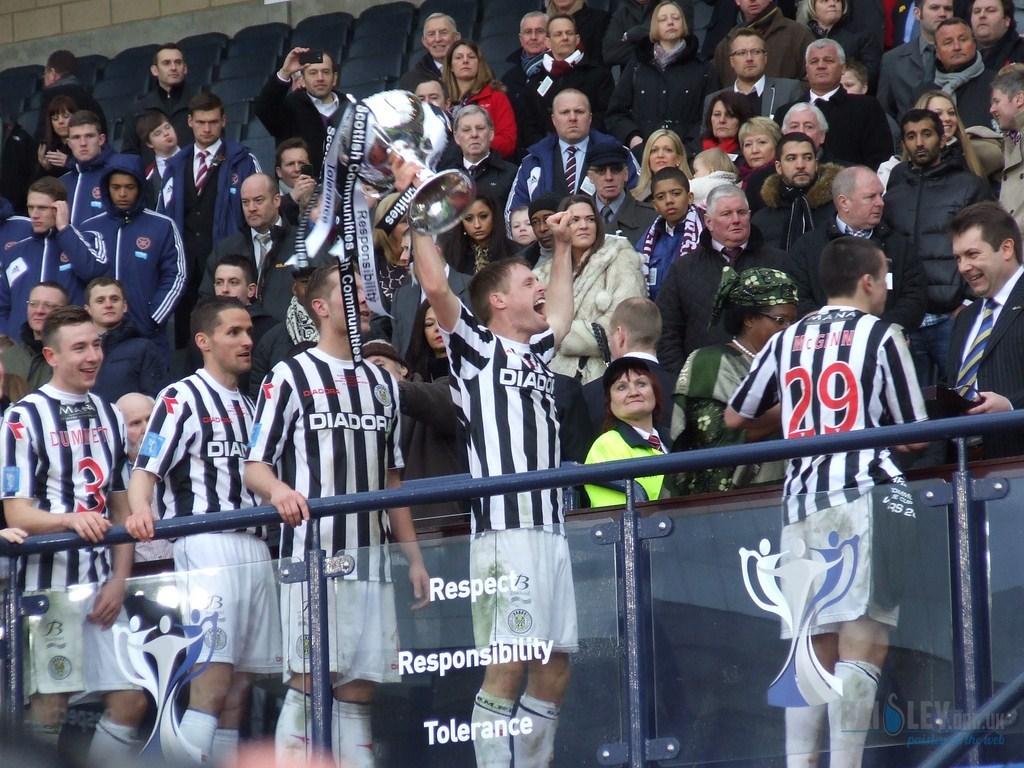What team names is on the front of the players shirts?
Your answer should be very brief. Diadora. 